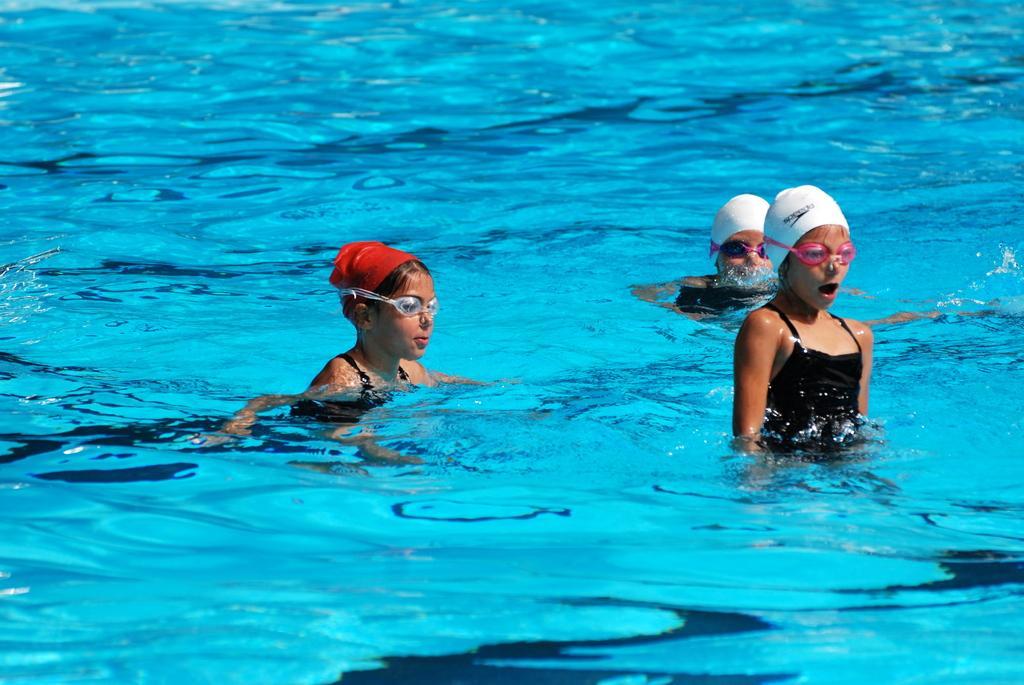Could you give a brief overview of what you see in this image? This image consists of three persons swimming. They are wearing caps. At the bottom, there is water. 